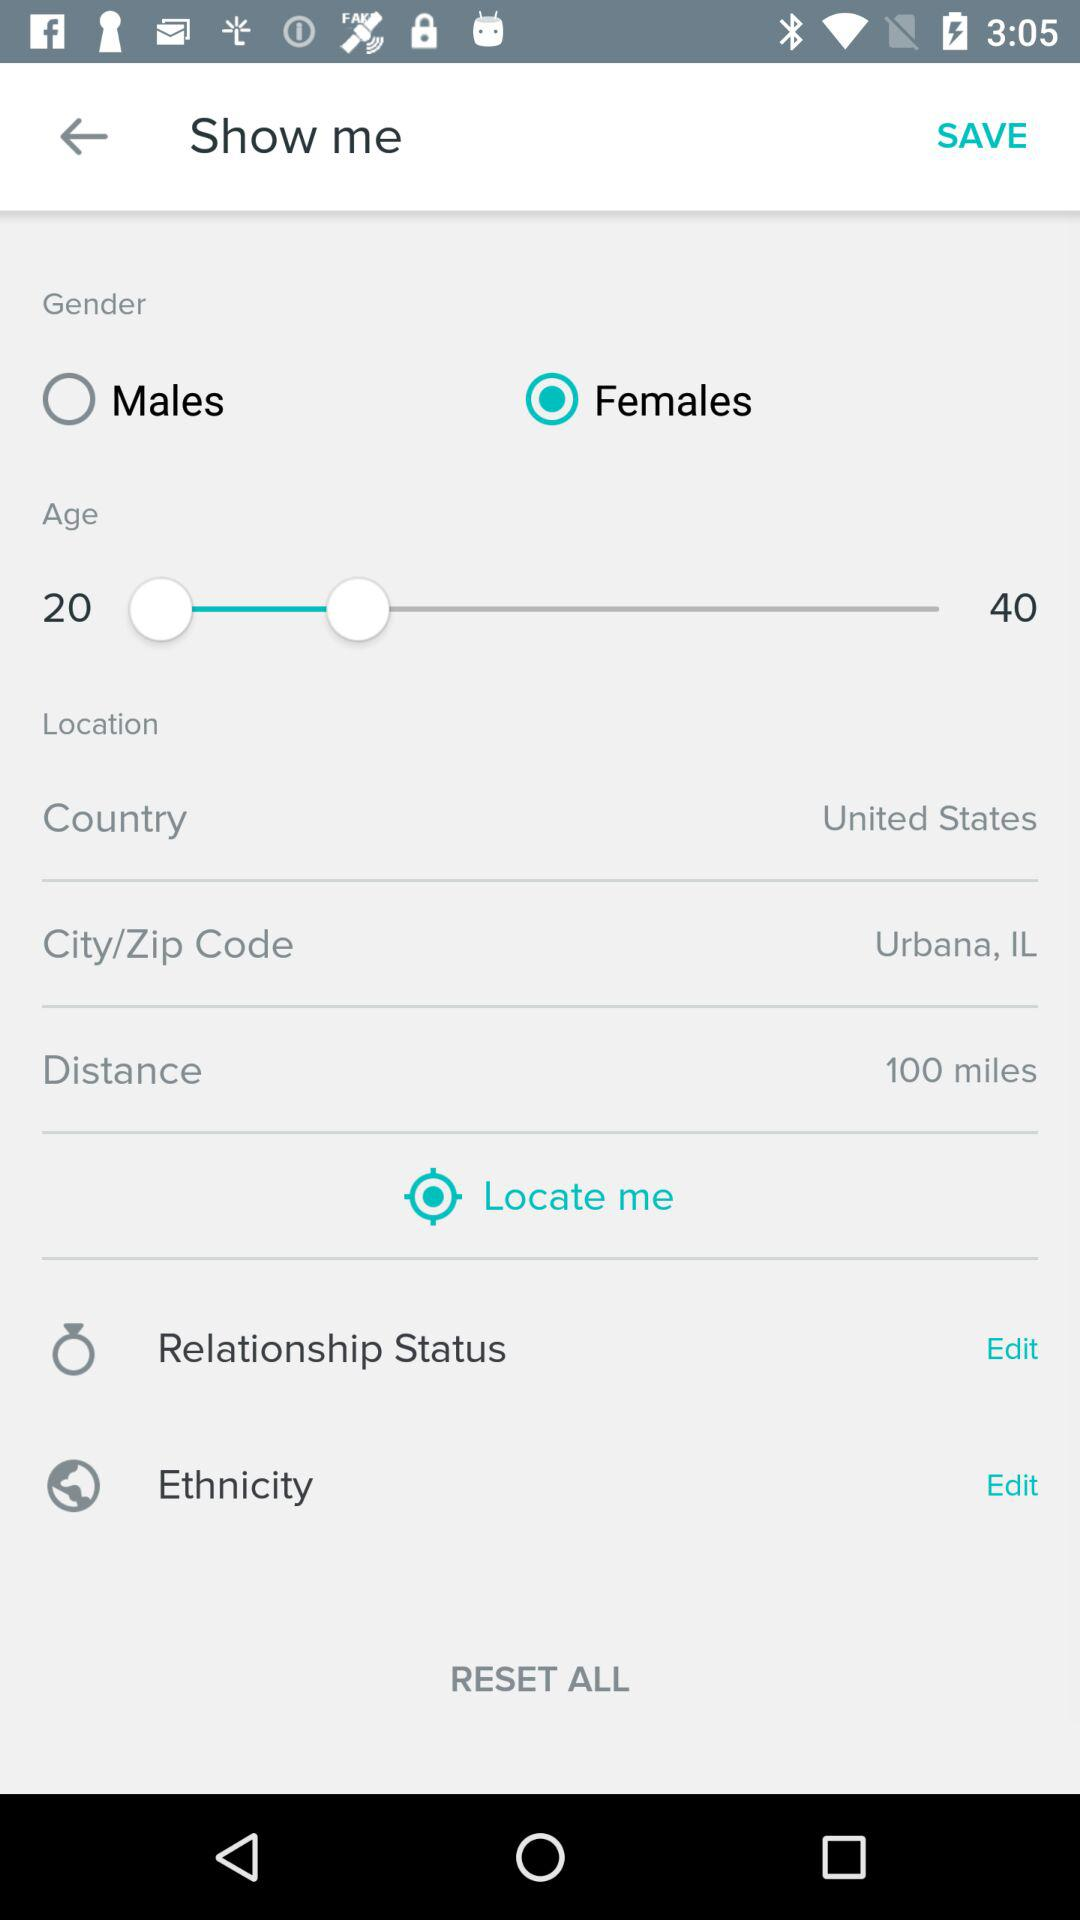What's the country? The country is the United States. 